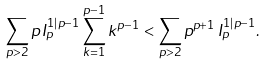Convert formula to latex. <formula><loc_0><loc_0><loc_500><loc_500>\sum _ { p > 2 } p \, I _ { p } ^ { 1 | p - 1 } \sum _ { k = 1 } ^ { p - 1 } k ^ { p - 1 } < \sum _ { p > 2 } p ^ { p + 1 } \, I _ { p } ^ { 1 | p - 1 } .</formula> 